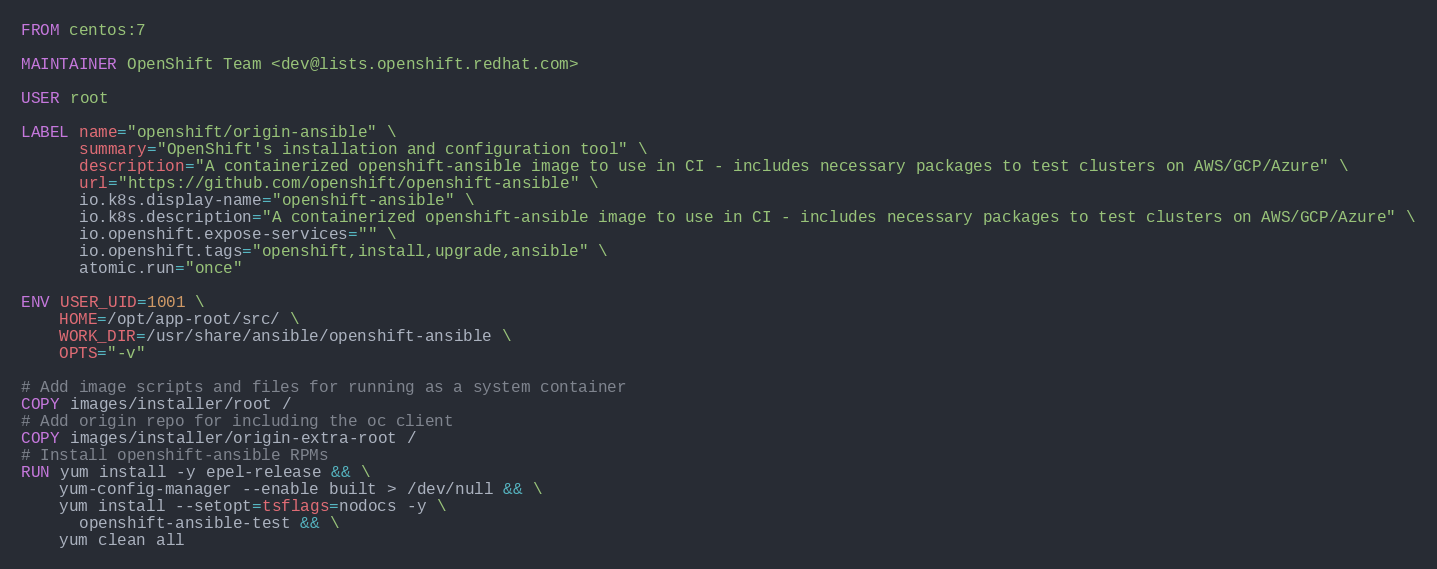<code> <loc_0><loc_0><loc_500><loc_500><_Dockerfile_>FROM centos:7

MAINTAINER OpenShift Team <dev@lists.openshift.redhat.com>

USER root

LABEL name="openshift/origin-ansible" \
      summary="OpenShift's installation and configuration tool" \
      description="A containerized openshift-ansible image to use in CI - includes necessary packages to test clusters on AWS/GCP/Azure" \
      url="https://github.com/openshift/openshift-ansible" \
      io.k8s.display-name="openshift-ansible" \
      io.k8s.description="A containerized openshift-ansible image to use in CI - includes necessary packages to test clusters on AWS/GCP/Azure" \
      io.openshift.expose-services="" \
      io.openshift.tags="openshift,install,upgrade,ansible" \
      atomic.run="once"

ENV USER_UID=1001 \
    HOME=/opt/app-root/src/ \
    WORK_DIR=/usr/share/ansible/openshift-ansible \
    OPTS="-v"

# Add image scripts and files for running as a system container
COPY images/installer/root /
# Add origin repo for including the oc client
COPY images/installer/origin-extra-root /
# Install openshift-ansible RPMs
RUN yum install -y epel-release && \
    yum-config-manager --enable built > /dev/null && \
    yum install --setopt=tsflags=nodocs -y \
      openshift-ansible-test && \
    yum clean all
</code> 